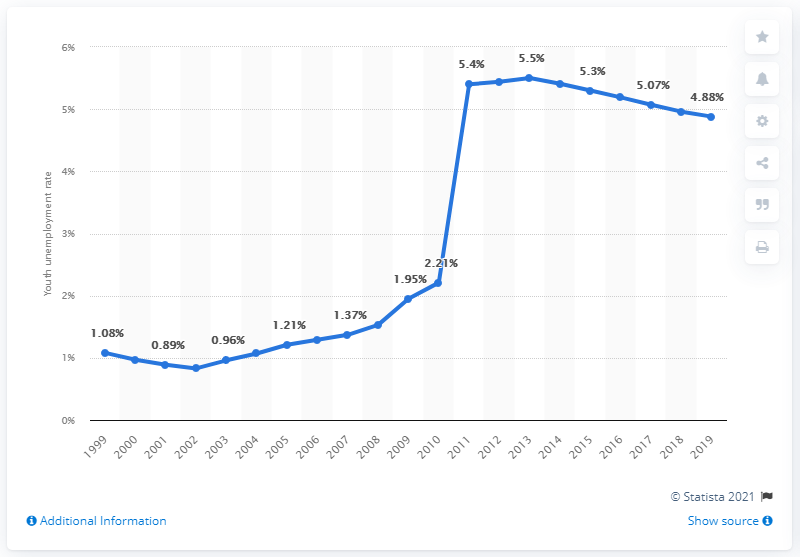Highlight a few significant elements in this photo. In 2019, the youth unemployment rate in Benin was 4.88%. This represents a significant challenge for the country's young population, as access to employment is crucial for their social and economic development. 